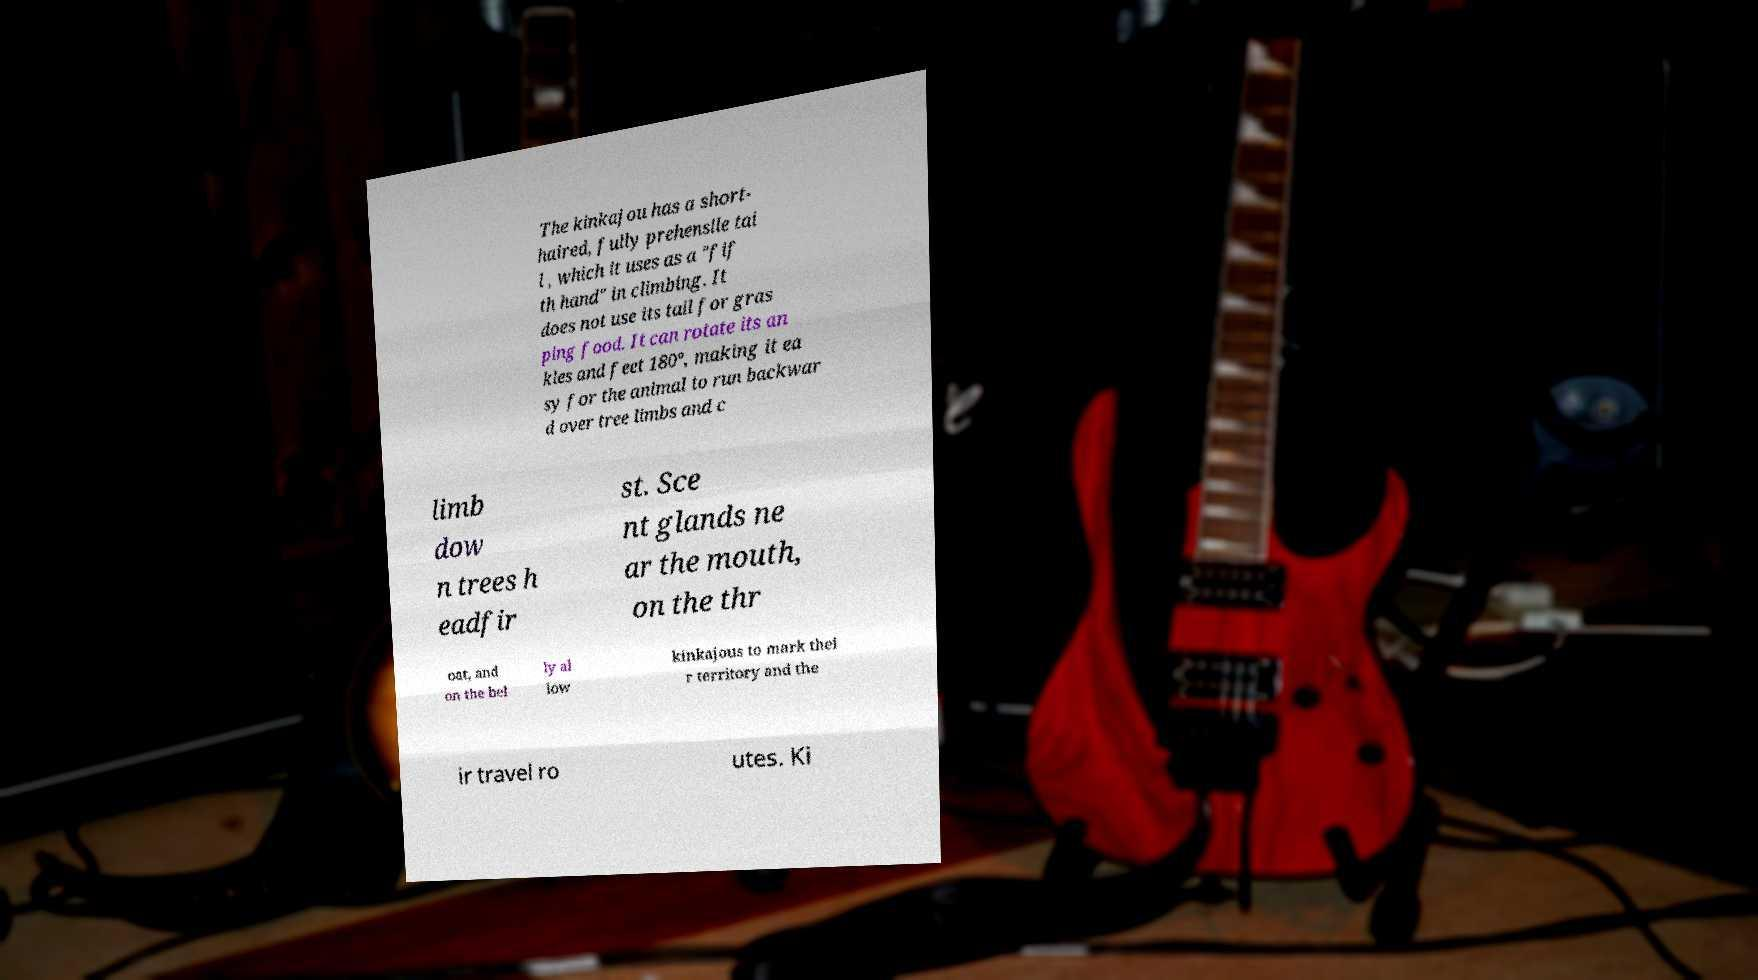For documentation purposes, I need the text within this image transcribed. Could you provide that? The kinkajou has a short- haired, fully prehensile tai l , which it uses as a "fif th hand" in climbing. It does not use its tail for gras ping food. It can rotate its an kles and feet 180°, making it ea sy for the animal to run backwar d over tree limbs and c limb dow n trees h eadfir st. Sce nt glands ne ar the mouth, on the thr oat, and on the bel ly al low kinkajous to mark thei r territory and the ir travel ro utes. Ki 